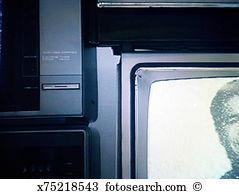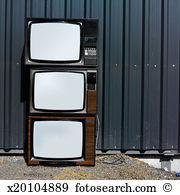The first image is the image on the left, the second image is the image on the right. Given the left and right images, does the statement "There is exactly one television in the right image and multiple televisions in the left image." hold true? Answer yes or no. No. The first image is the image on the left, the second image is the image on the right. For the images displayed, is the sentence "the right image contains 1 tv" factually correct? Answer yes or no. No. 